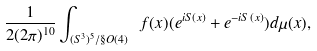Convert formula to latex. <formula><loc_0><loc_0><loc_500><loc_500>\frac { 1 } { 2 ( 2 \pi ) ^ { 1 0 } } \int _ { ( S ^ { 3 } ) ^ { 5 } / \S O ( 4 ) } \ f ( x ) ( e ^ { i S ( x ) } + e ^ { - i S ( x ) } ) d \mu ( x ) ,</formula> 